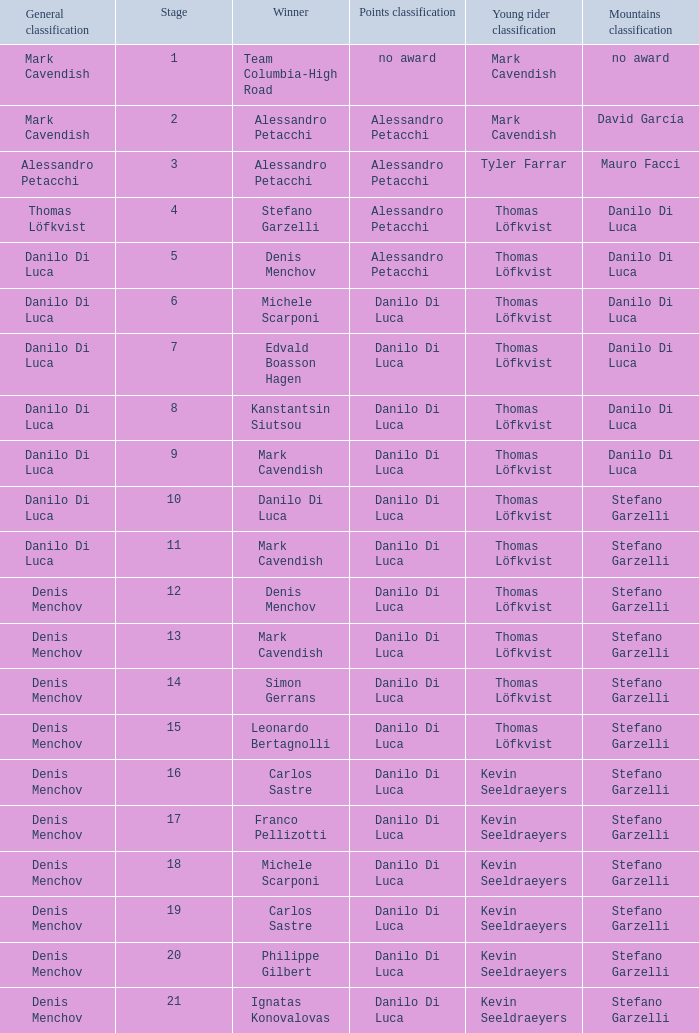When thomas löfkvist is the  young rider classification and alessandro petacchi is the points classification who are the general classifications?  Thomas Löfkvist, Danilo Di Luca. 